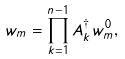Convert formula to latex. <formula><loc_0><loc_0><loc_500><loc_500>w _ { m } = \prod _ { k = 1 } ^ { n - 1 } A _ { k } ^ { \dagger } w _ { m } ^ { 0 } ,</formula> 